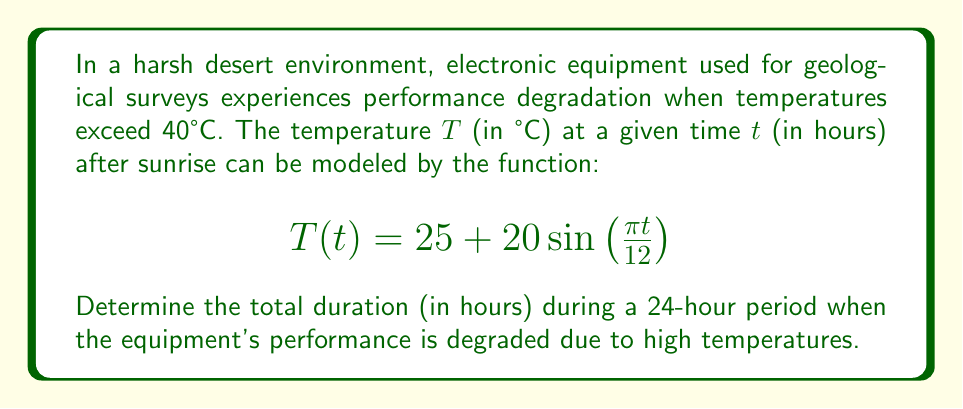Solve this math problem. 1) First, we need to find when the temperature exceeds 40°C. This occurs when:

   $$40 = 25 + 20\sin\left(\frac{\pi t}{12}\right)$$

2) Solving for the sine term:

   $$\sin\left(\frac{\pi t}{12}\right) = \frac{15}{20} = 0.75$$

3) Taking the inverse sine (arcsin) of both sides:

   $$\frac{\pi t}{12} = \arcsin(0.75)$$

4) Solving for t:

   $$t = \frac{12}{\pi} \arcsin(0.75) \approx 3.18$$

5) This gives us the time when the temperature first reaches 40°C. Due to the symmetry of the sine function, the temperature will drop below 40°C after the same interval past the peak (which occurs at t = 6).

6) So, the end time is:

   $$6 + (6 - 3.18) = 8.82$$

7) The total duration is:

   $$8.82 - 3.18 = 5.64$$

Therefore, the equipment's performance is degraded for approximately 5.64 hours each day.
Answer: 5.64 hours 